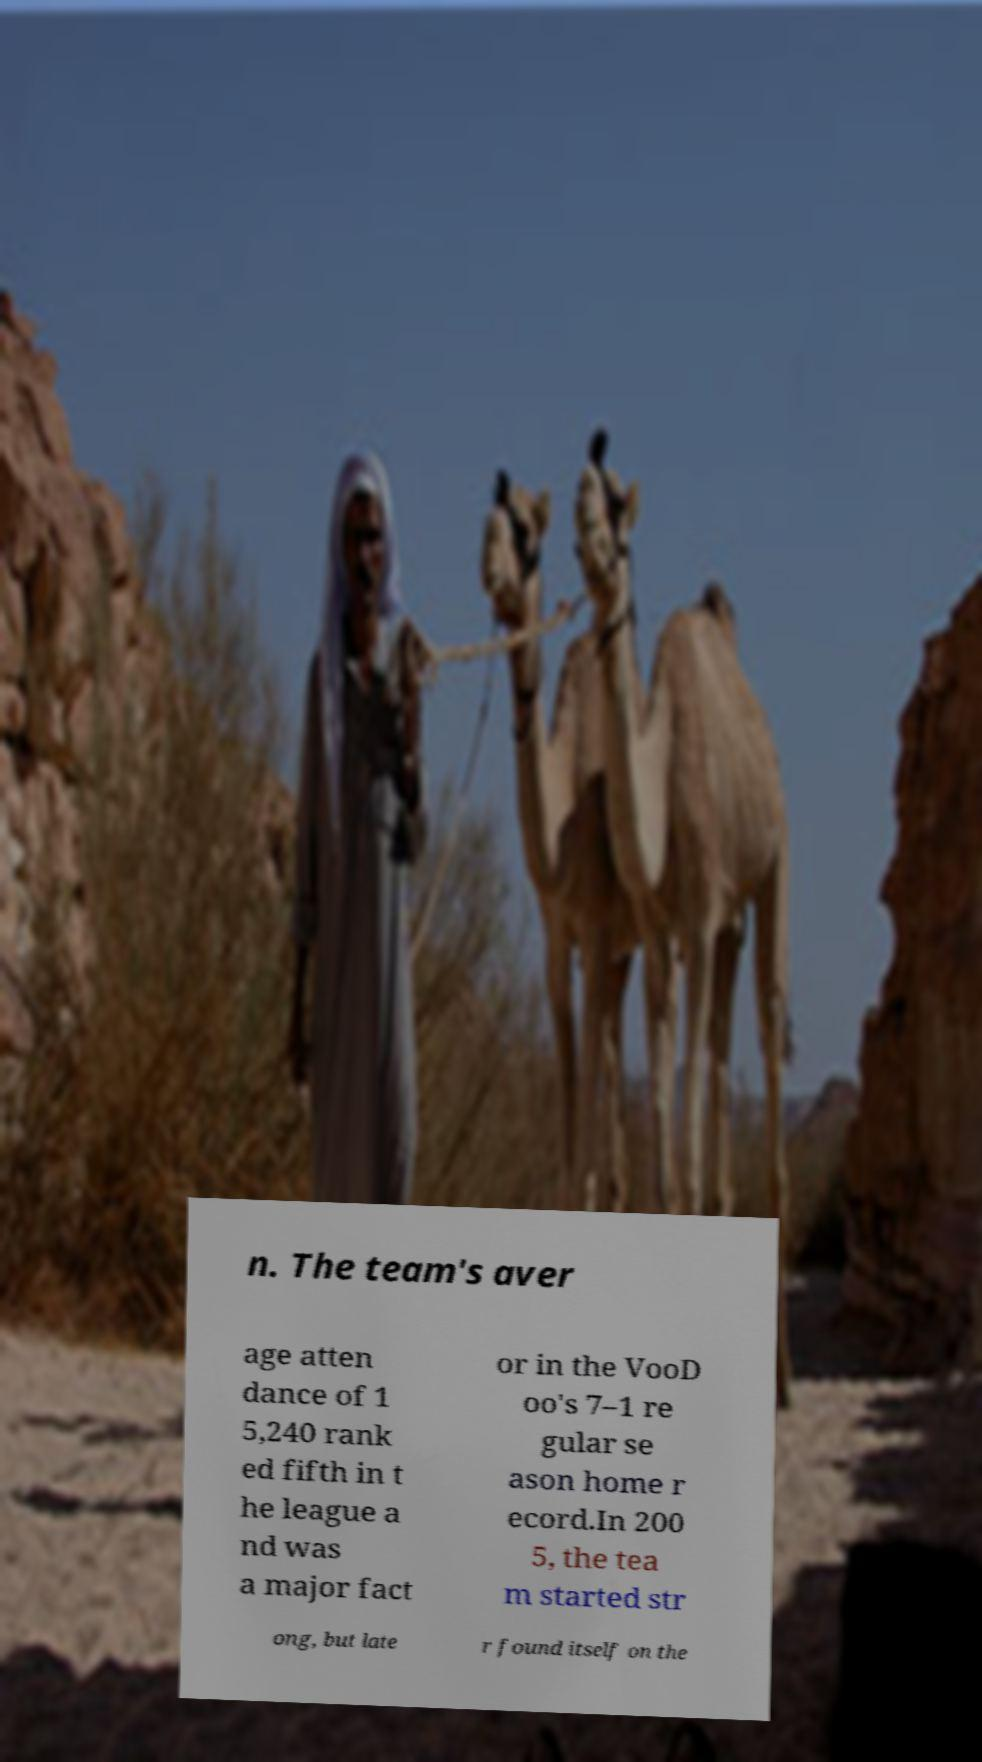Please identify and transcribe the text found in this image. n. The team's aver age atten dance of 1 5,240 rank ed fifth in t he league a nd was a major fact or in the VooD oo's 7–1 re gular se ason home r ecord.In 200 5, the tea m started str ong, but late r found itself on the 